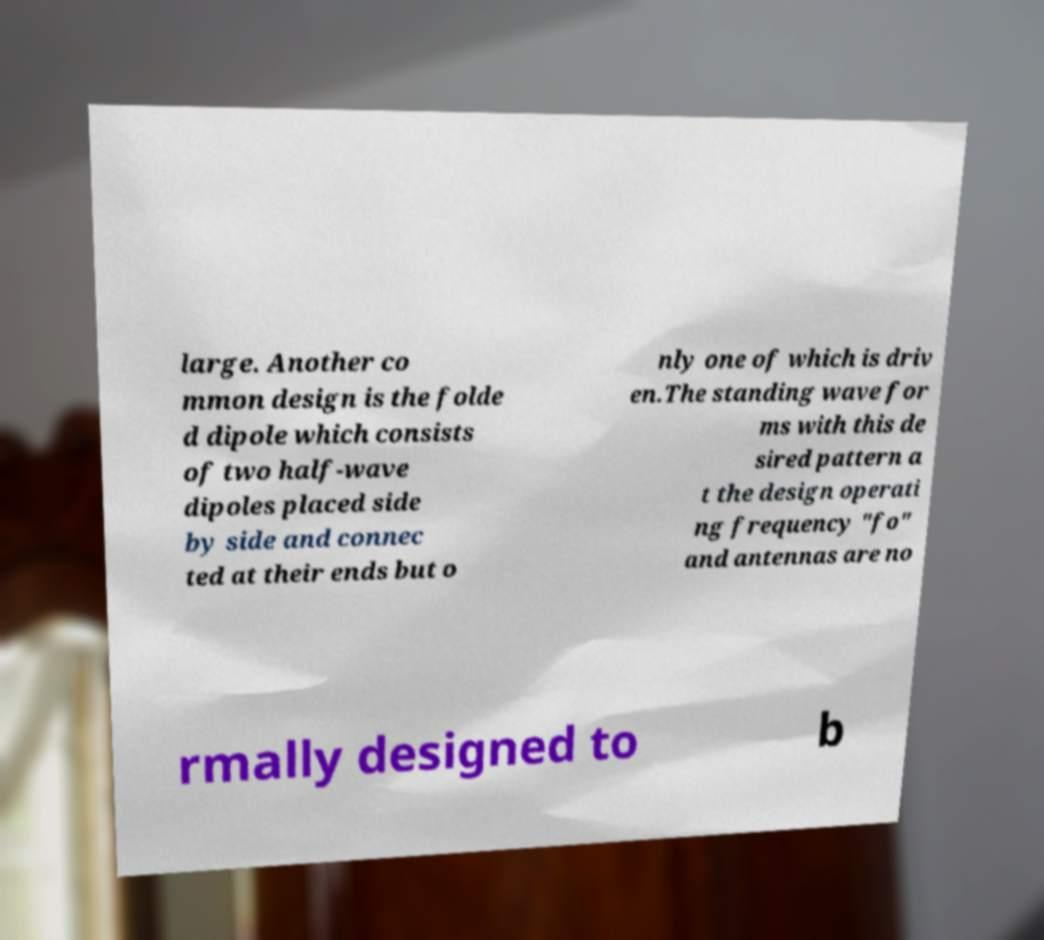For documentation purposes, I need the text within this image transcribed. Could you provide that? large. Another co mmon design is the folde d dipole which consists of two half-wave dipoles placed side by side and connec ted at their ends but o nly one of which is driv en.The standing wave for ms with this de sired pattern a t the design operati ng frequency "fo" and antennas are no rmally designed to b 